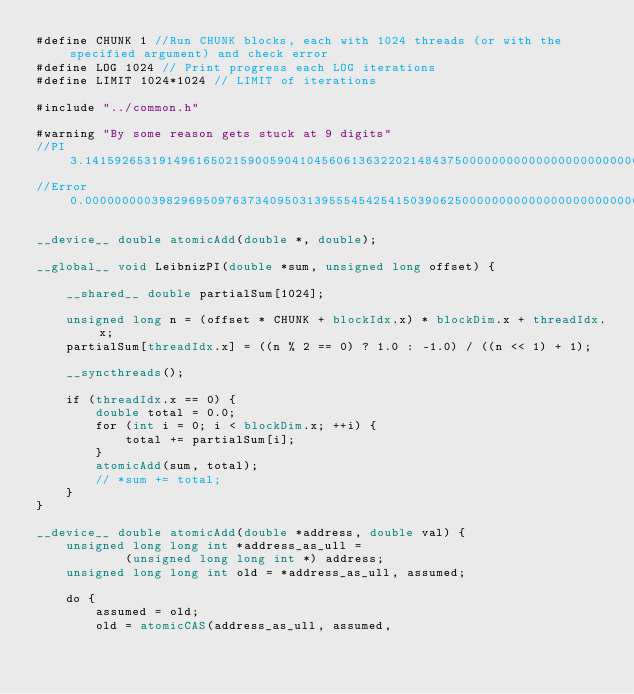<code> <loc_0><loc_0><loc_500><loc_500><_Cuda_>#define CHUNK 1 //Run CHUNK blocks, each with 1024 threads (or with the specified argument) and check error
#define LOG 1024 // Print progress each LOG iterations
#define LIMIT 1024*1024 // LIMIT of iterations

#include "../common.h"

#warning "By some reason gets stuck at 9 digits"
//PI		3.1415926531914961650215900590410456061363220214843750000000000000000000000000000000000000000000000000
//Error		0.0000000003982969509763734095031395554542541503906250000000000000000000000000000000000000000000000000

__device__ double atomicAdd(double *, double);

__global__ void LeibnizPI(double *sum, unsigned long offset) {

    __shared__ double partialSum[1024];

    unsigned long n = (offset * CHUNK + blockIdx.x) * blockDim.x + threadIdx.x;
    partialSum[threadIdx.x] = ((n % 2 == 0) ? 1.0 : -1.0) / ((n << 1) + 1);

    __syncthreads();

    if (threadIdx.x == 0) {
        double total = 0.0;
        for (int i = 0; i < blockDim.x; ++i) {
            total += partialSum[i];
        }
        atomicAdd(sum, total);
        // *sum += total;
    }
}

__device__ double atomicAdd(double *address, double val) {
    unsigned long long int *address_as_ull =
            (unsigned long long int *) address;
    unsigned long long int old = *address_as_ull, assumed;

    do {
        assumed = old;
        old = atomicCAS(address_as_ull, assumed,</code> 